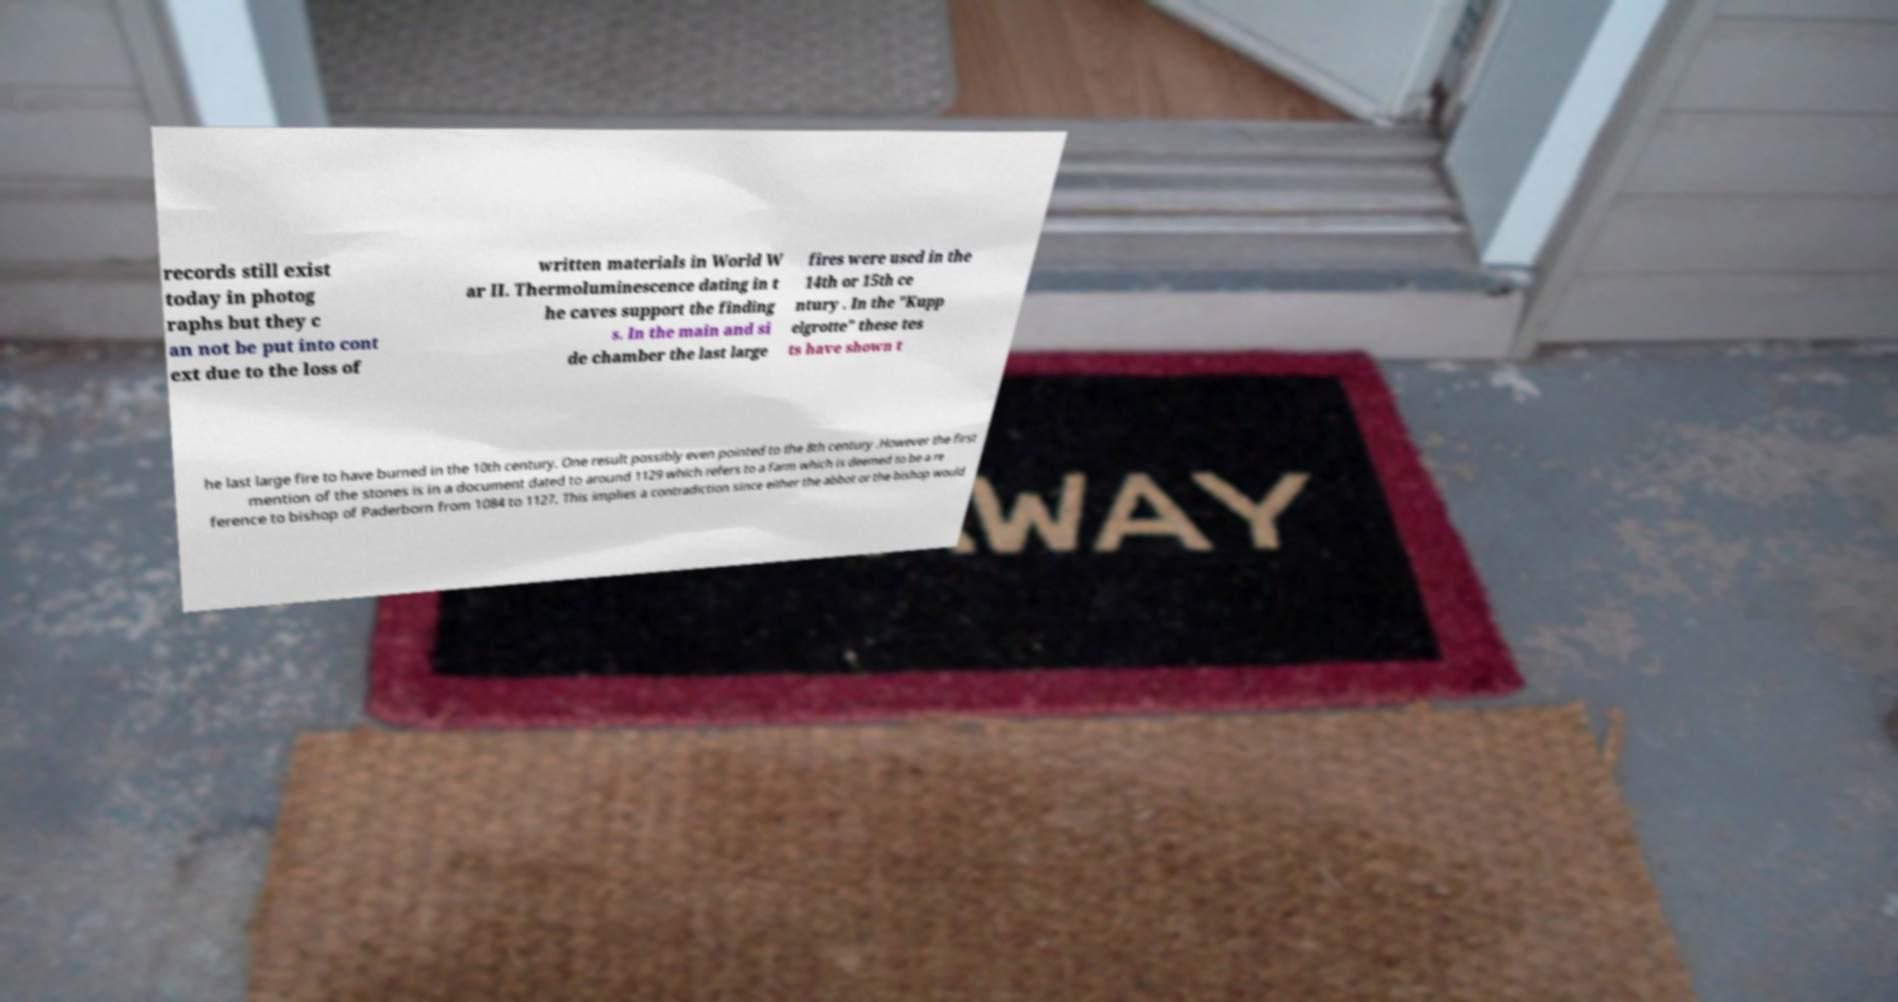Can you read and provide the text displayed in the image?This photo seems to have some interesting text. Can you extract and type it out for me? records still exist today in photog raphs but they c an not be put into cont ext due to the loss of written materials in World W ar II. Thermoluminescence dating in t he caves support the finding s. In the main and si de chamber the last large fires were used in the 14th or 15th ce ntury . In the "Kupp elgrotte" these tes ts have shown t he last large fire to have burned in the 10th century. One result possibly even pointed to the 8th century .However the first mention of the stones is in a document dated to around 1129 which refers to a farm which is deemed to be a re ference to bishop of Paderborn from 1084 to 1127. This implies a contradiction since either the abbot or the bishop would 